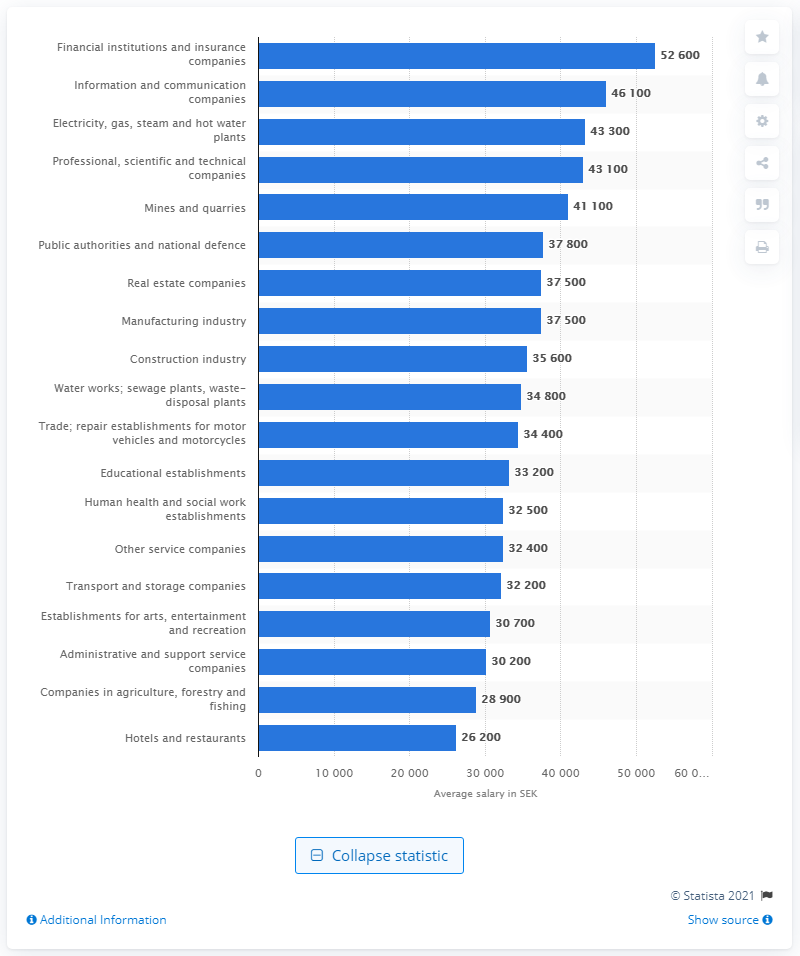Highlight a few significant elements in this photo. According to data collected in 2019, the average monthly salary for employees at companies within the sector was approximately 52,600 U.S. dollars. 